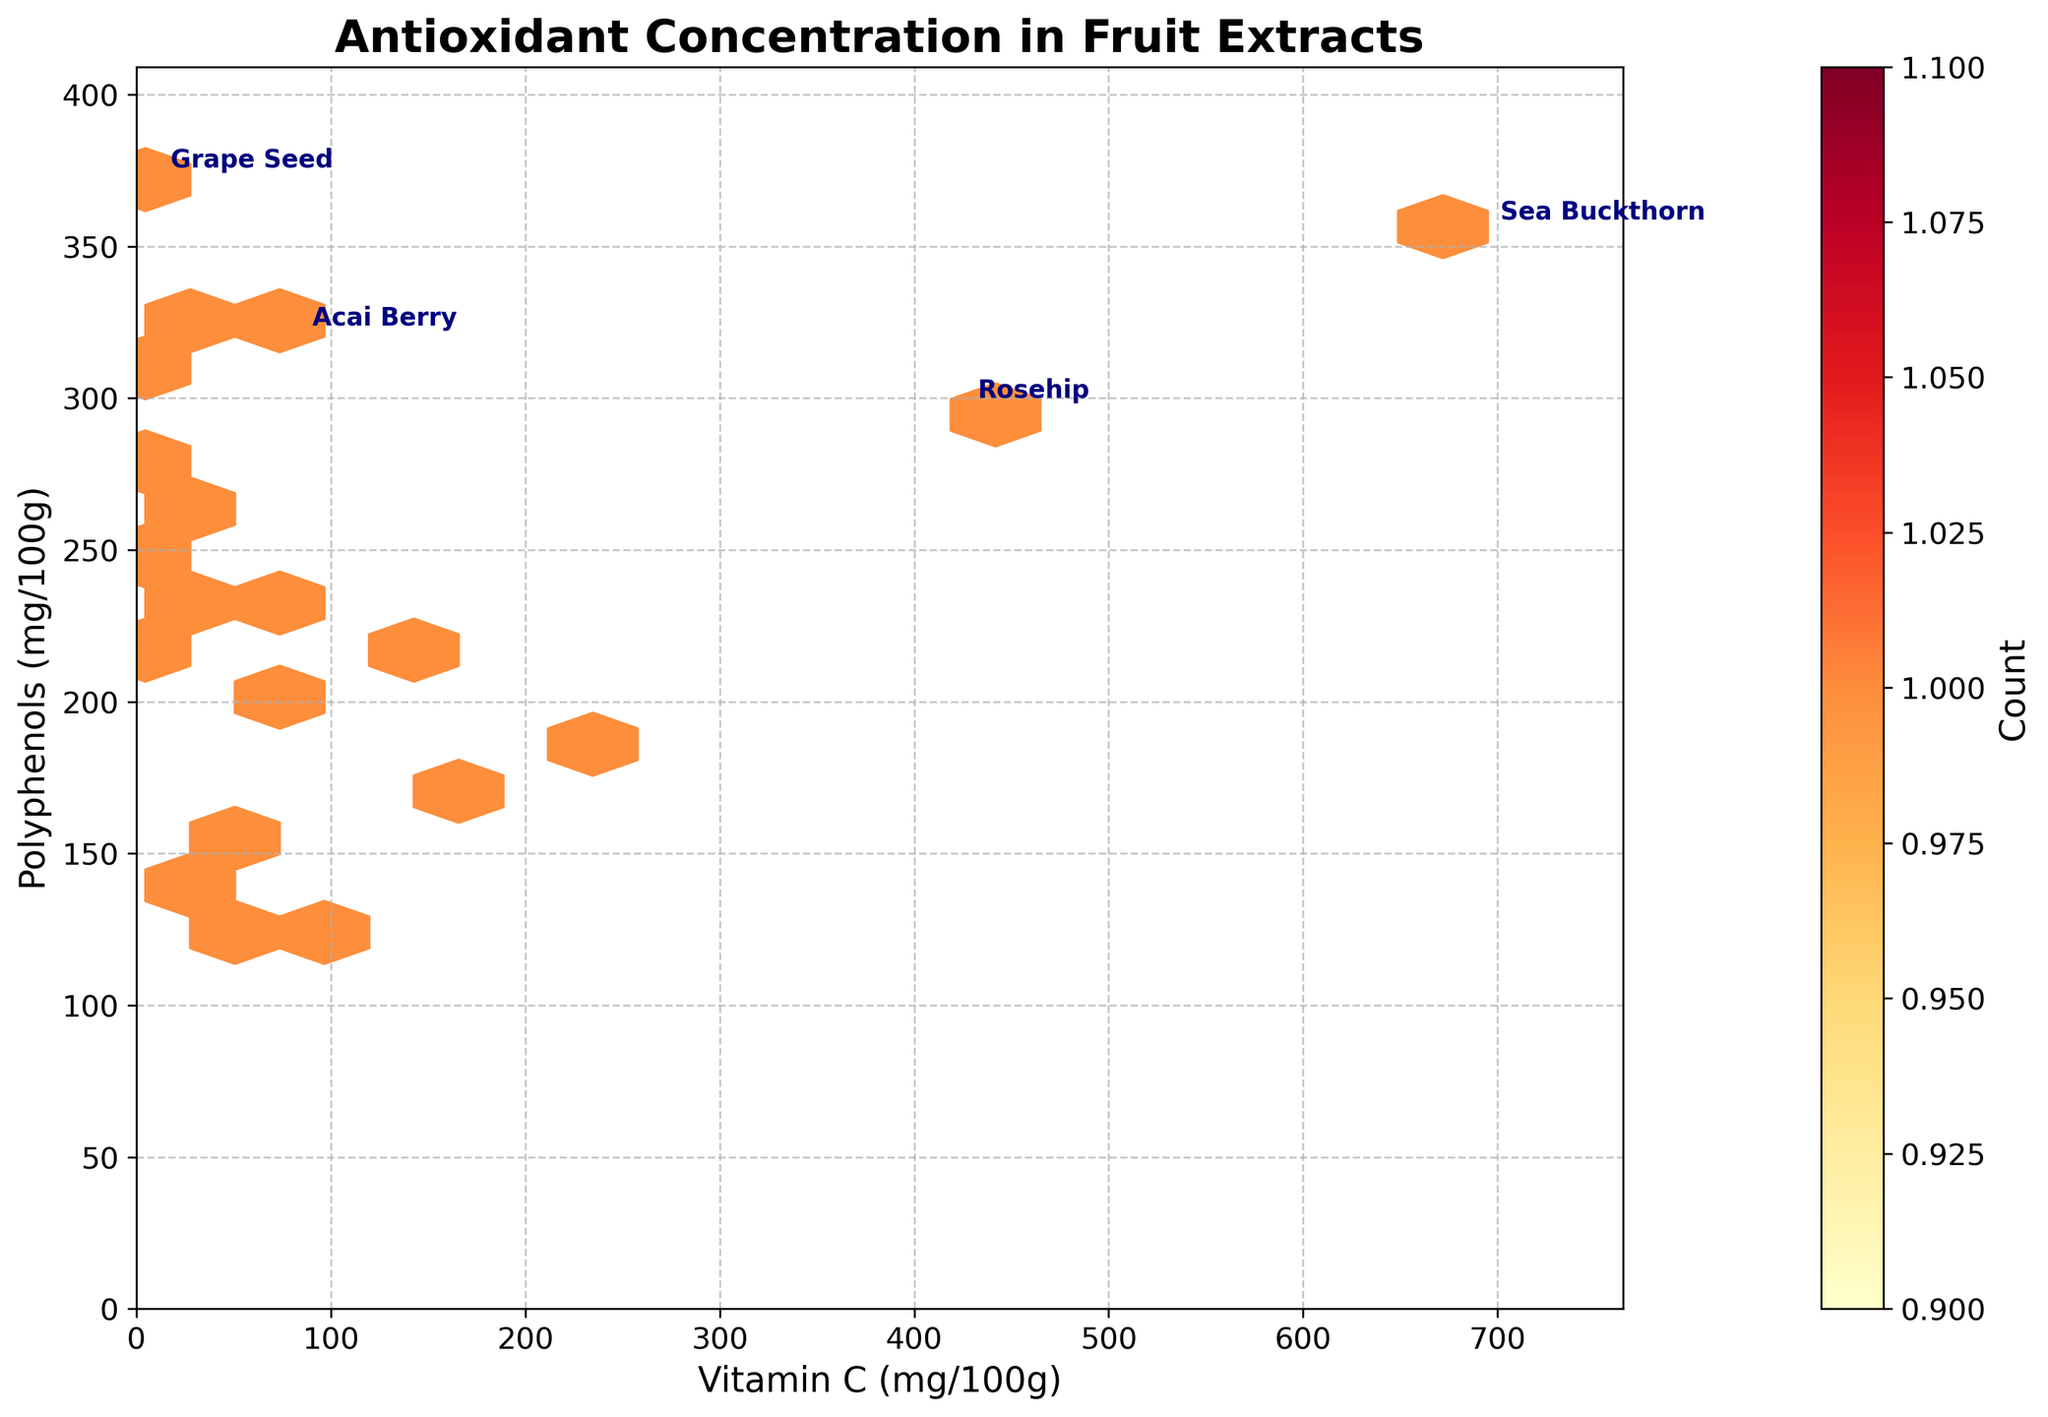What is the title of the hexbin plot? The title is located at the top of the plot, usually in a larger, bold font. It provides an overview of the data being visualized.
Answer: Antioxidant Concentration in Fruit Extracts What does the color scale represent in the figure? The color scale, typically a color bar on the side of the plot, shows the count of data points that fall within each hexagonal bin. Darker colors indicate higher counts.
Answer: Count What are the units for the x-axis? The x-axis label provides the units of measurement for Vitamin C concentration in the fruit extracts, stated in mg per 100 grams.
Answer: mg/100g Which fruit extracts have been annotated in the figure? The annotations are extra labels placed next to certain data points; these are Sea Buckthorn, Rosehip, Acai Berry, and Grape Seed.
Answer: Sea Buckthorn, Rosehip, Acai Berry, Grape Seed Which fruit extract has the highest concentration of Vitamin C and what is that concentration? By examining the x-axis and locating the data point farthest to the right, we identify that Sea Buckthorn has the highest concentration at approximately 695 mg/100g.
Answer: Sea Buckthorn, 695 mg/100g How does the concentration of Polyphenols in Grape Seed compare to that in Rosehip? Observing the y-axis and comparing the heights of the corresponding points for Grape Seed and Rosehip shows Grape Seed has a slightly higher concentration of Polyphenols.
Answer: Grape Seed has a higher concentration than Rosehip What is the average concentration of Vitamin C in the annotated fruit extracts? Identifying the Vitamin C values of the annotated extracts: Sea Buckthorn (695), Rosehip (426), Acai Berry (84), Grape Seed (11). Summing these and dividing by 4 gives an average. (695 + 426 + 84 + 11) / 4 = 304
Answer: 304 mg/100g In which range of Vitamin C and Polyphenols do the highest data point counts fall? By analyzing the densest hexbin regions, we can visually estimate the range with the highest concentration of data points in terms of Vitamin C and Polyphenols.
Answer: Vitamin C: 10-100 mg/100g, Polyphenols: 200-300 mg/100g Is there a general trend between Vitamin C and Polyphenol concentrations in these fruit extracts? Observing the overall distribution of points, there does not appear to be a clear positive or negative correlation, indicating no strong trend.
Answer: No clear trend What does the grid size in the hexbin plot indicate? The grid size determines the number of hexagonal bins across the x and y axes, affecting the resolution of the plot. A finer grid size can show more detail in the data distribution.
Answer: 15 